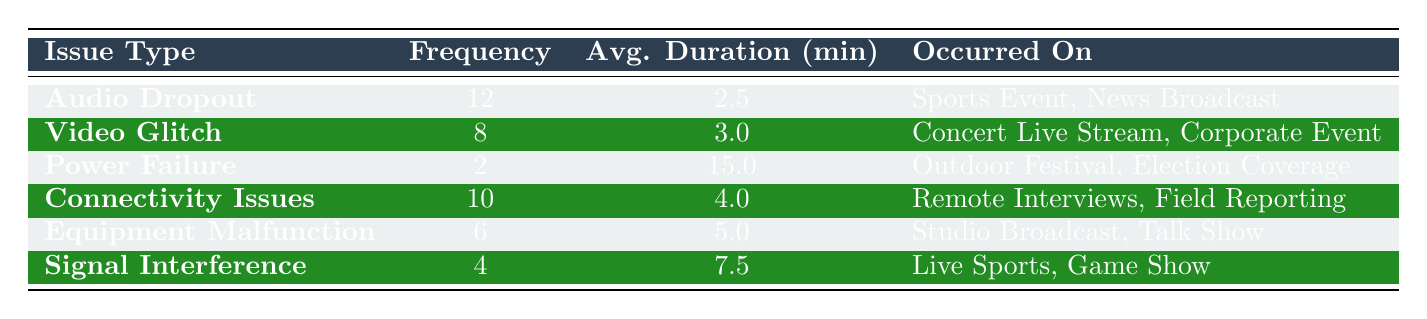What is the frequency of Audio Dropout issues? According to the table, the frequency column for Audio Dropout shows a value of 12.
Answer: 12 Which technical issue has the longest average duration? By comparing the average duration for all technical issues listed in the table, Power Failure has an average duration of 15.0 minutes, which is greater than the others.
Answer: Power Failure How many total occurrences of technical issues are recorded in the table? To find the total occurrences, we sum the frequency of all issues: 12 (Audio Dropout) + 8 (Video Glitch) + 2 (Power Failure) + 10 (Connectivity Issues) + 6 (Equipment Malfunction) + 4 (Signal Interference) = 42.
Answer: 42 Is it true that Signal Interference issues occur more frequently than Equipment Malfunction issues? Comparing the frequency values in the table, Signal Interference has a frequency of 4, while Equipment Malfunction has a frequency of 6, therefore it is false that Signal Interference occurs more frequently.
Answer: No What is the average duration of Connectivity Issues? The average duration for Connectivity Issues is listed in the table as 4.0 minutes.
Answer: 4.0 If you combine the frequencies of Audio Dropout and Connectivity Issues, what is the total? Summing the frequencies of Audio Dropout (12) and Connectivity Issues (10) gives: 12 + 10 = 22.
Answer: 22 How many technical issues are there with an average duration longer than 5 minutes? By checking each issue, only Power Failure (15.0) and Signal Interference (7.5) have an average duration longer than 5 minutes, totaling 2 issues.
Answer: 2 Which event type is most commonly associated with audio dropout issues? The table indicates that Audio Dropout issues occurred during Sports Events and News Broadcasts. Thus, both are common, but no single type is predominant.
Answer: Sports Event, News Broadcast Are Video Glitch issues less frequent than both Equipment Malfunction and Connectivity Issues? The frequency of Video Glitch is 8, Equipment Malfunction is 6, and Connectivity Issues is 10. Since 8 is not less than both 6 and 10, the claim is false.
Answer: No 